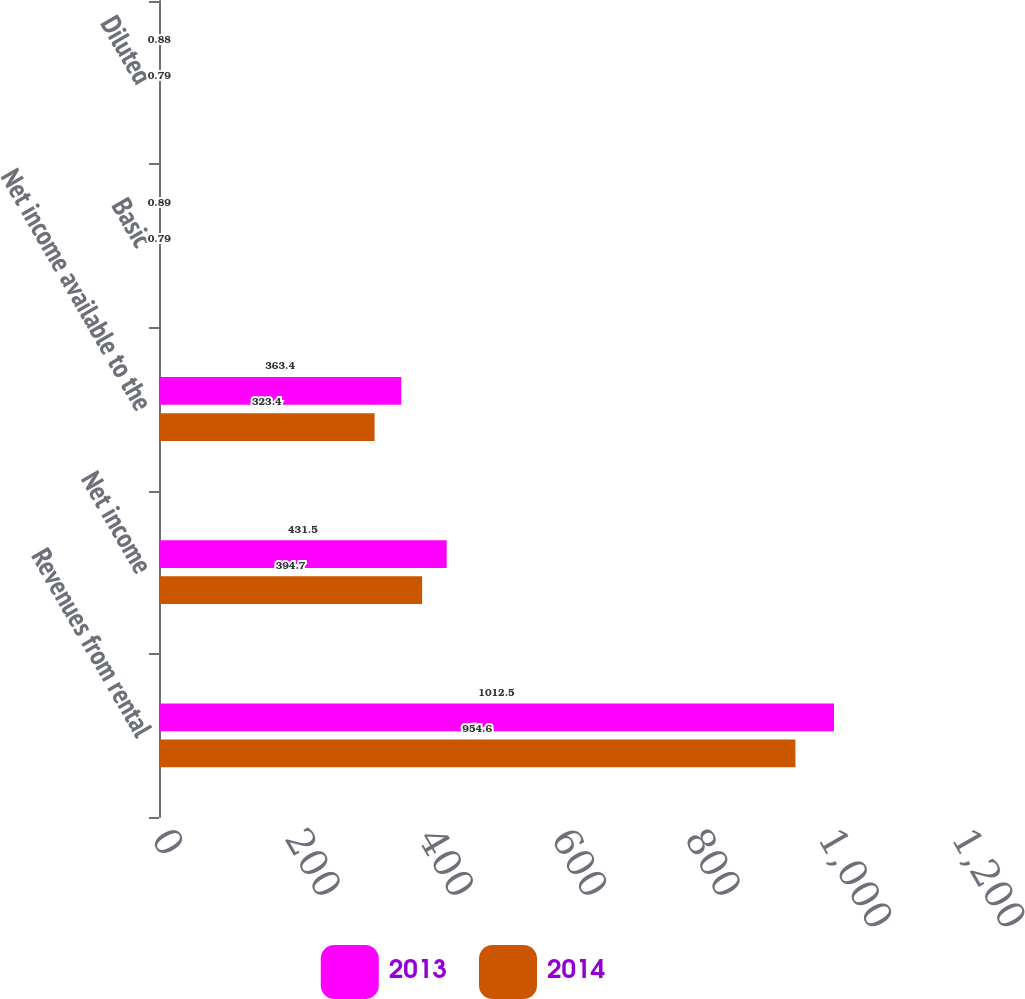Convert chart. <chart><loc_0><loc_0><loc_500><loc_500><stacked_bar_chart><ecel><fcel>Revenues from rental<fcel>Net income<fcel>Net income available to the<fcel>Basic<fcel>Diluted<nl><fcel>2013<fcel>1012.5<fcel>431.5<fcel>363.4<fcel>0.89<fcel>0.88<nl><fcel>2014<fcel>954.6<fcel>394.7<fcel>323.4<fcel>0.79<fcel>0.79<nl></chart> 